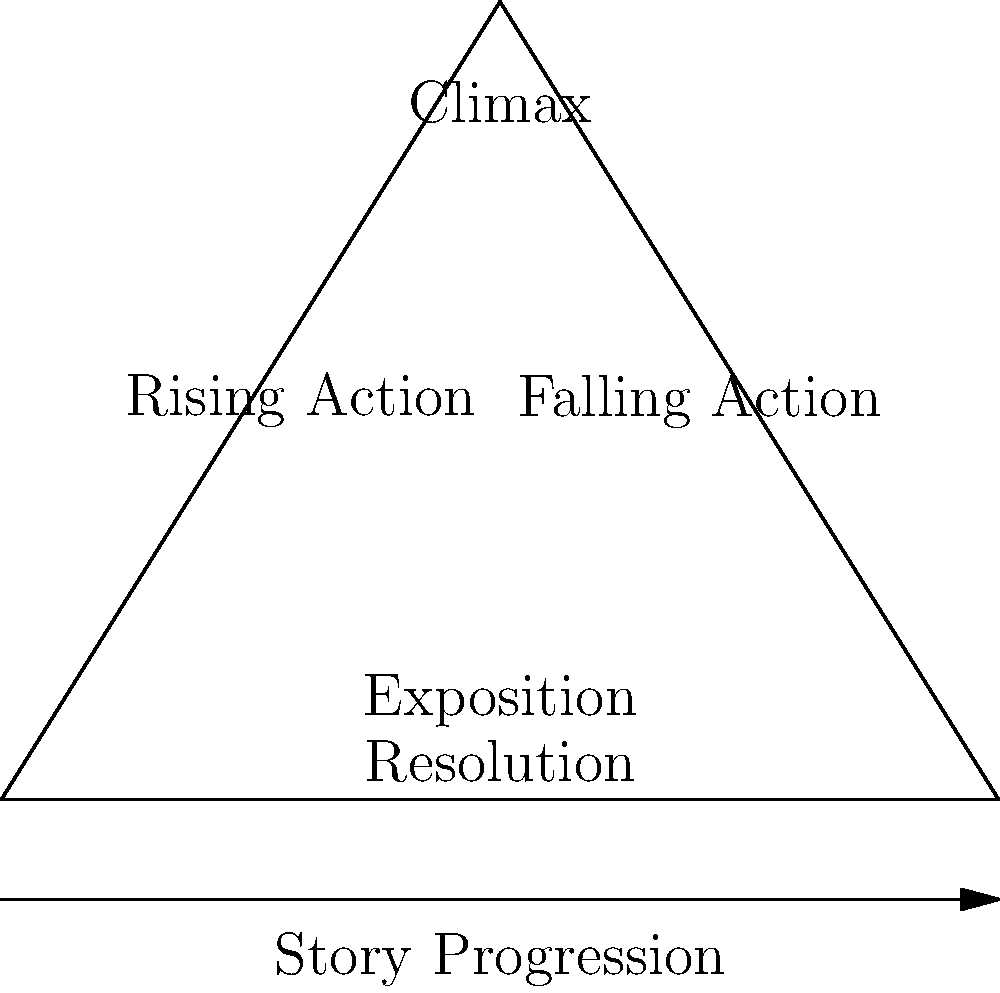As a seasoned author guiding local writers, how would you explain the significance of the "Climax" position in this story structure pyramid, and why is it crucial for maintaining reader engagement throughout the narrative? 1. Position: The "Climax" is placed at the apex of the pyramid, representing the highest point of tension in the story.

2. Story progression: As we move from left to right and bottom to top, we see the story building up towards the climax.

3. Tension build-up: The "Rising Action" leads to the climax, creating anticipation and increasing stakes for the characters.

4. Peak moment: The climax is the turning point of the story, where the main conflict reaches its highest intensity.

5. Reader engagement: The climax keeps readers invested by providing a payoff for the buildup of tension and conflict.

6. Resolution initiation: After the climax, the "Falling Action" begins, leading to the resolution of the story's conflicts.

7. Structure balance: The climax's central position creates a balanced structure, with equal parts building up to and resolving from this pivotal moment.

8. Pacing tool: Authors can use the climax as a reference point to pace their story, ensuring proper development and resolution.

9. Character development: The climax often showcases the protagonist's growth and decisive actions, culminating their character arc.

10. Theme reinforcement: The climax typically embodies the story's central theme or message, giving it maximum impact.
Answer: The climax, positioned at the pyramid's apex, is crucial for maintaining reader engagement as it represents the story's highest point of tension, provides a payoff for the built-up anticipation, and serves as a pivotal moment for character development and theme reinforcement. 